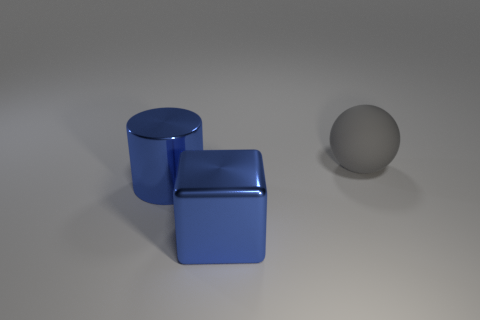What color is the large object that is behind the big object left of the shiny thing that is in front of the large blue cylinder? gray 